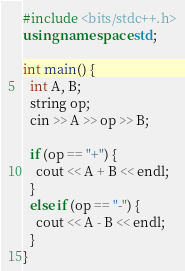Convert code to text. <code><loc_0><loc_0><loc_500><loc_500><_C++_>#include <bits/stdc++.h>
using namespace std;
 
int main() {
  int A, B;
  string op;
  cin >> A >> op >> B;
 
  if (op == "+") {
    cout << A + B << endl;
  }
  else if (op == "-") {
    cout << A - B << endl;
  }
}</code> 